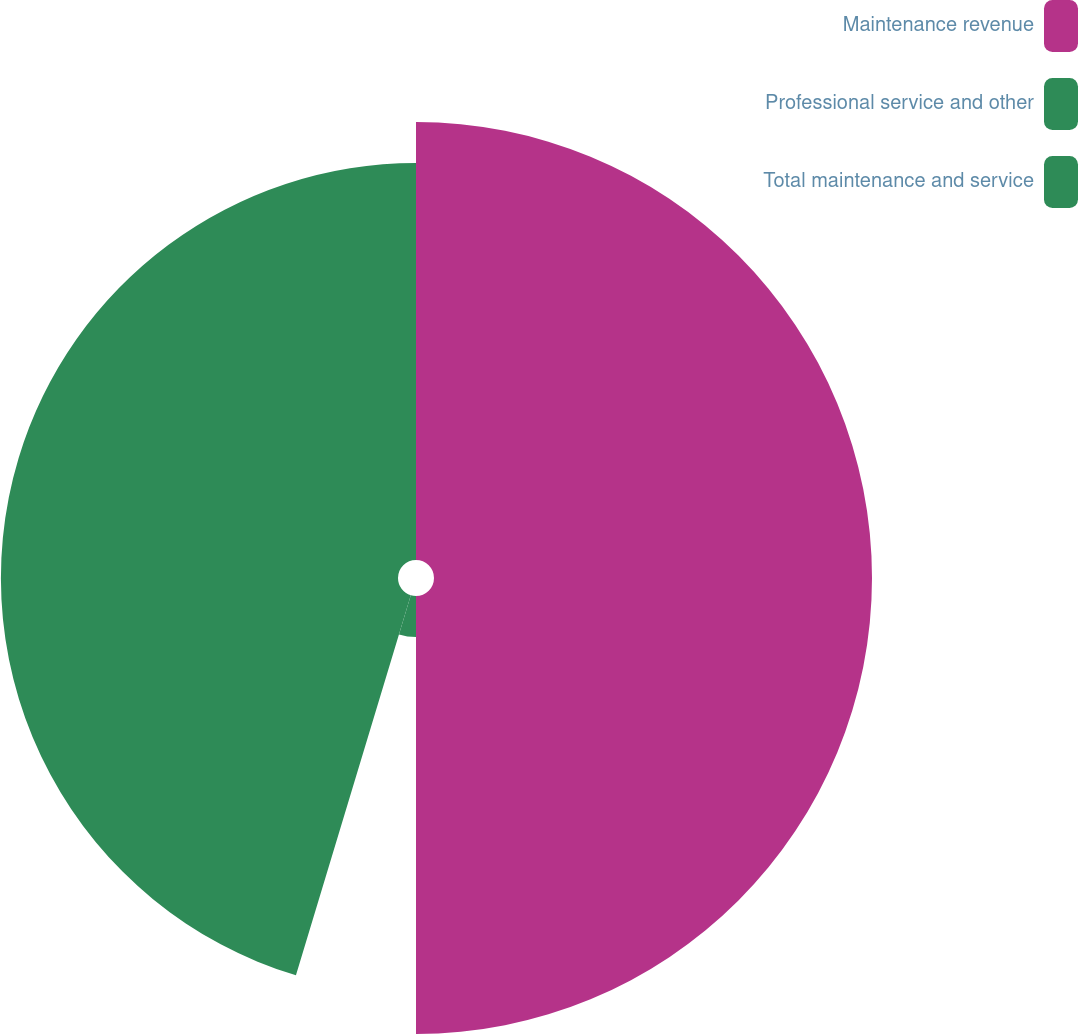<chart> <loc_0><loc_0><loc_500><loc_500><pie_chart><fcel>Maintenance revenue<fcel>Professional service and other<fcel>Total maintenance and service<nl><fcel>50.0%<fcel>4.67%<fcel>45.33%<nl></chart> 